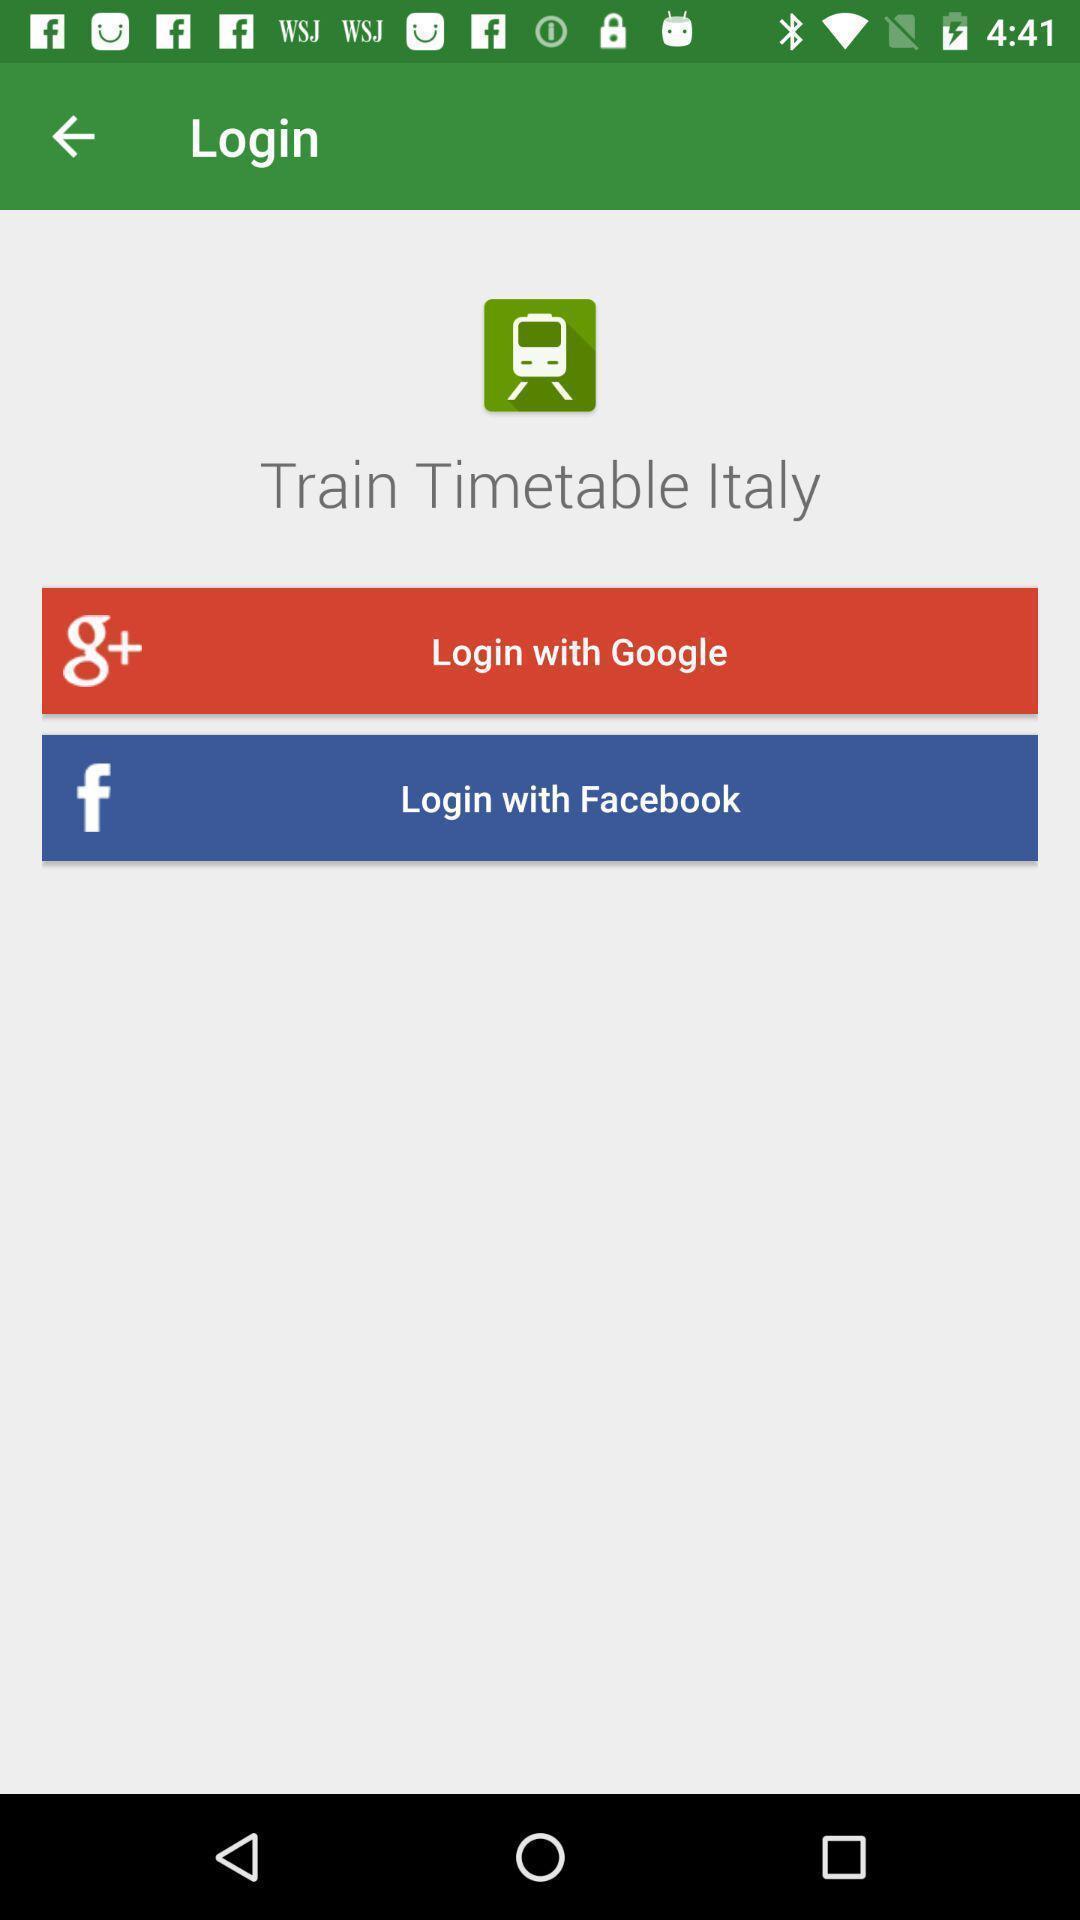Describe the visual elements of this screenshot. Welcome page of a social app. 